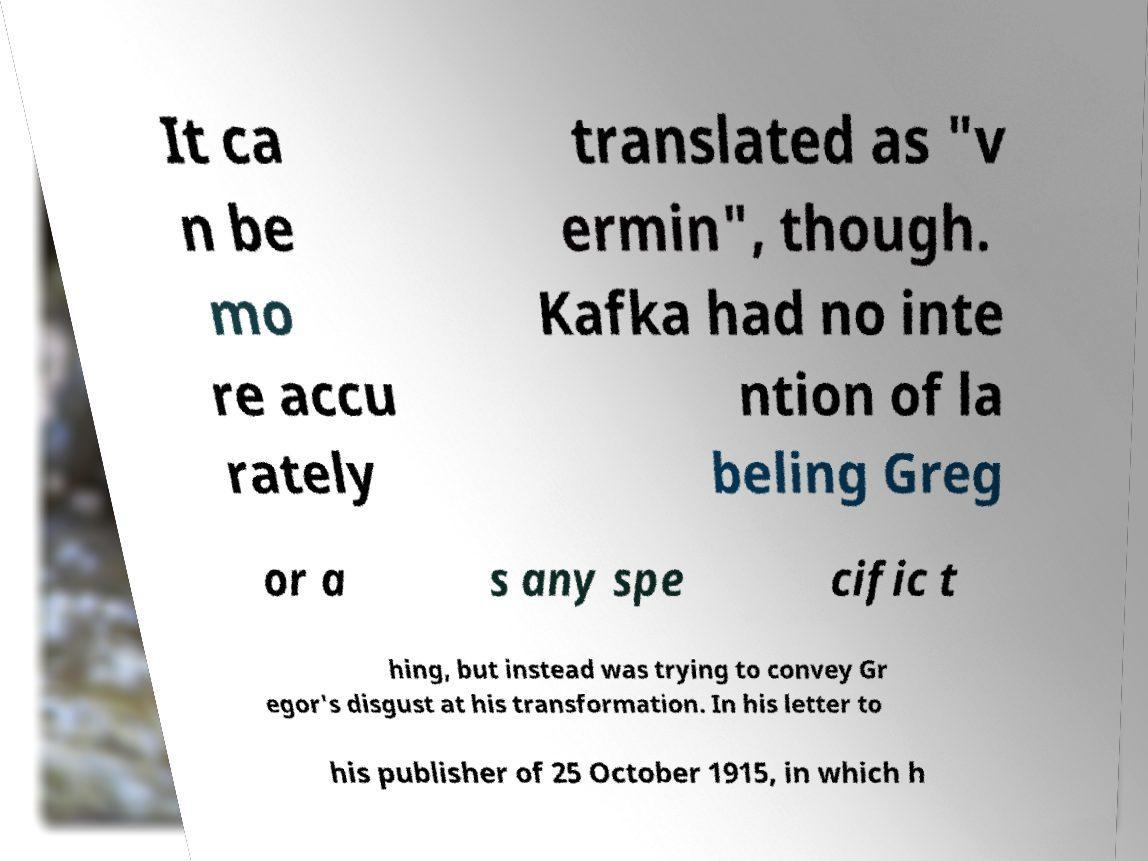Could you extract and type out the text from this image? It ca n be mo re accu rately translated as "v ermin", though. Kafka had no inte ntion of la beling Greg or a s any spe cific t hing, but instead was trying to convey Gr egor's disgust at his transformation. In his letter to his publisher of 25 October 1915, in which h 